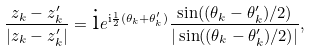Convert formula to latex. <formula><loc_0><loc_0><loc_500><loc_500>\frac { z _ { k } - z _ { k } ^ { \prime } } { | z _ { k } - z _ { k } ^ { \prime } | } = \text  i e^{\text  i\frac{1}{2}(\theta_{k}+\theta_{k}^{\prime})} \frac { \sin ( ( \theta _ { k } - \theta _ { k } ^ { \prime } ) / 2 ) } { | \sin ( ( \theta _ { k } - \theta _ { k } ^ { \prime } ) / 2 ) | } ,</formula> 